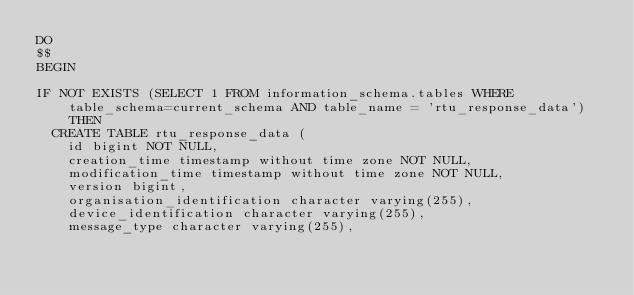<code> <loc_0><loc_0><loc_500><loc_500><_SQL_>DO
$$
BEGIN

IF NOT EXISTS (SELECT 1 FROM information_schema.tables WHERE table_schema=current_schema AND table_name = 'rtu_response_data') THEN
  CREATE TABLE rtu_response_data (
    id bigint NOT NULL,
    creation_time timestamp without time zone NOT NULL,
    modification_time timestamp without time zone NOT NULL,
    version bigint,
    organisation_identification character varying(255),
    device_identification character varying(255),
    message_type character varying(255),</code> 